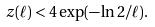<formula> <loc_0><loc_0><loc_500><loc_500>z ( \ell ) < 4 \exp ( - \ln 2 / \ell ) .</formula> 